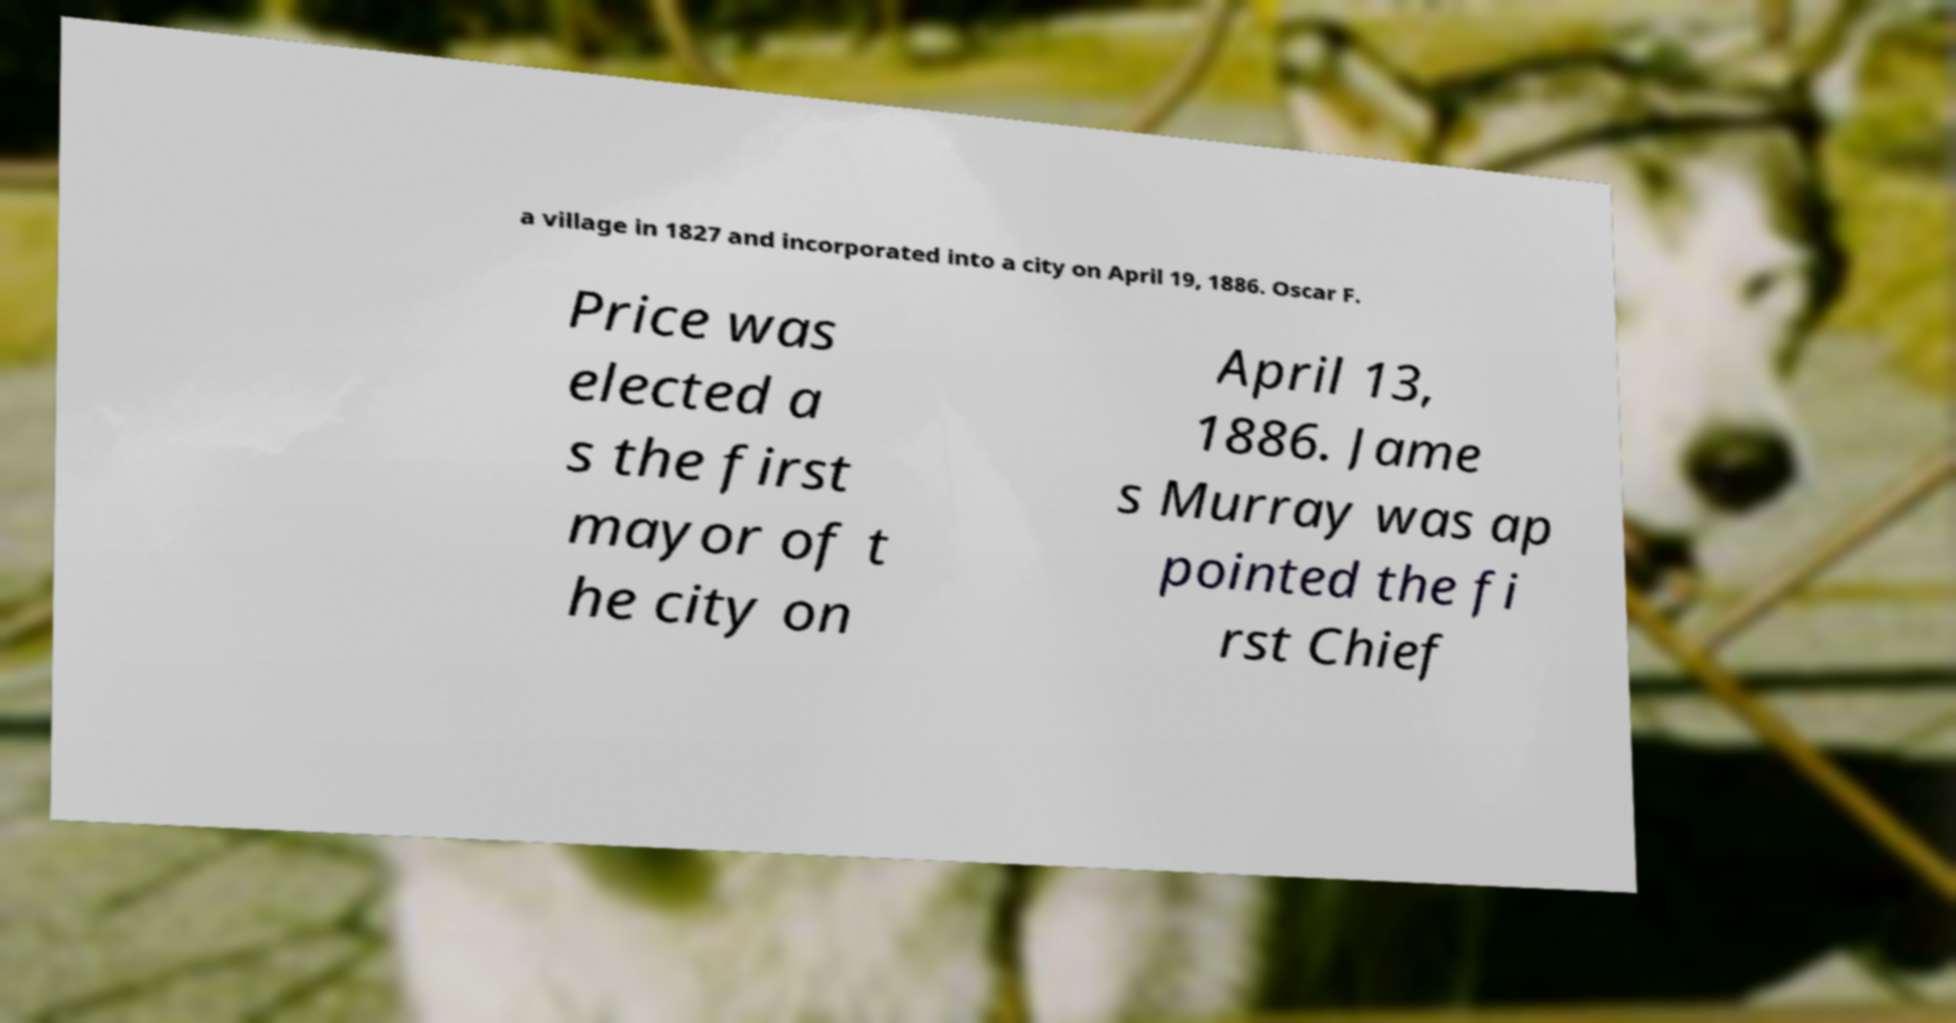I need the written content from this picture converted into text. Can you do that? a village in 1827 and incorporated into a city on April 19, 1886. Oscar F. Price was elected a s the first mayor of t he city on April 13, 1886. Jame s Murray was ap pointed the fi rst Chief 